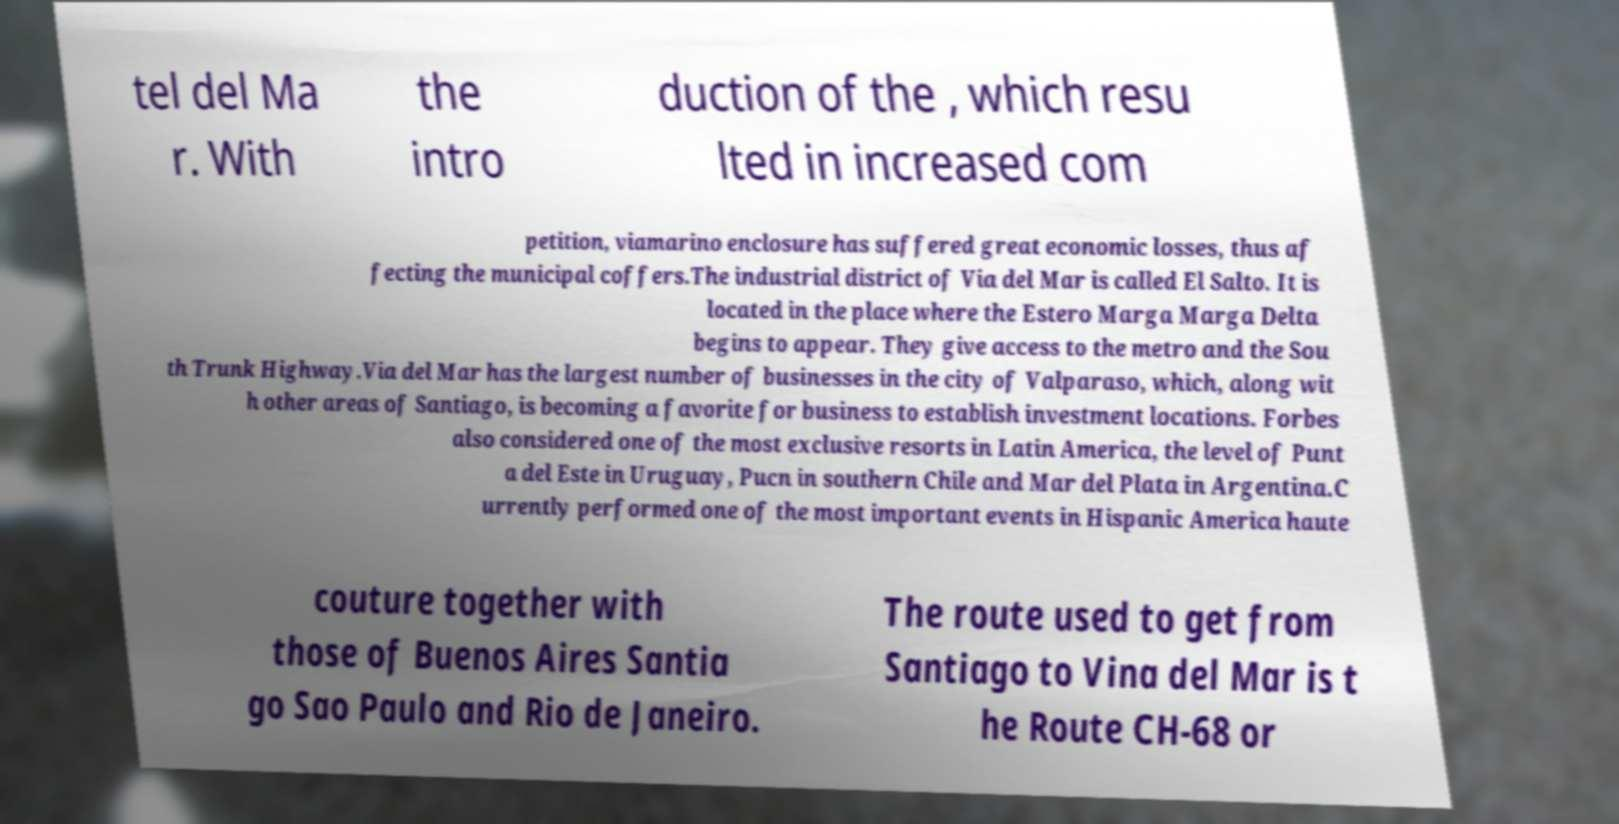Could you assist in decoding the text presented in this image and type it out clearly? tel del Ma r. With the intro duction of the , which resu lted in increased com petition, viamarino enclosure has suffered great economic losses, thus af fecting the municipal coffers.The industrial district of Via del Mar is called El Salto. It is located in the place where the Estero Marga Marga Delta begins to appear. They give access to the metro and the Sou th Trunk Highway.Via del Mar has the largest number of businesses in the city of Valparaso, which, along wit h other areas of Santiago, is becoming a favorite for business to establish investment locations. Forbes also considered one of the most exclusive resorts in Latin America, the level of Punt a del Este in Uruguay, Pucn in southern Chile and Mar del Plata in Argentina.C urrently performed one of the most important events in Hispanic America haute couture together with those of Buenos Aires Santia go Sao Paulo and Rio de Janeiro. The route used to get from Santiago to Vina del Mar is t he Route CH-68 or 